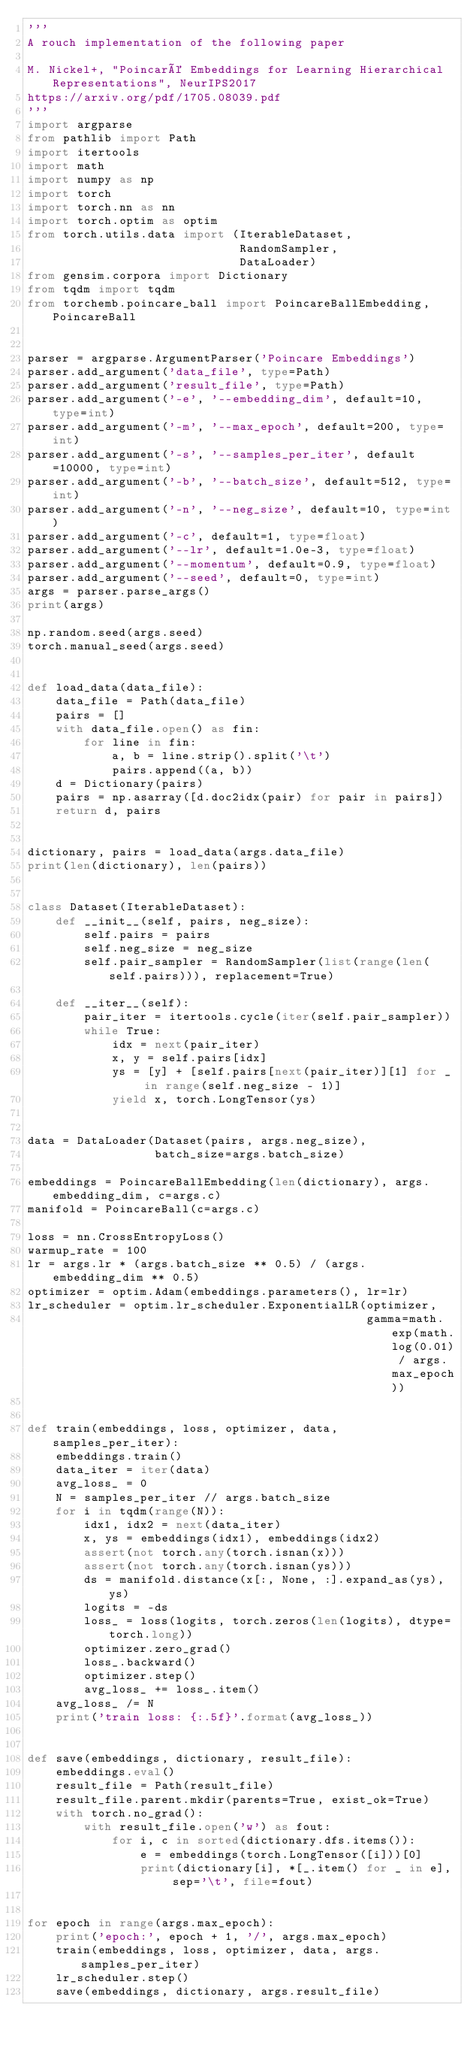<code> <loc_0><loc_0><loc_500><loc_500><_Python_>'''
A rouch implementation of the following paper

M. Nickel+, "Poincaré Embeddings for Learning Hierarchical Representations", NeurIPS2017
https://arxiv.org/pdf/1705.08039.pdf
'''
import argparse
from pathlib import Path
import itertools
import math
import numpy as np
import torch
import torch.nn as nn
import torch.optim as optim
from torch.utils.data import (IterableDataset,
                              RandomSampler,
                              DataLoader)
from gensim.corpora import Dictionary
from tqdm import tqdm
from torchemb.poincare_ball import PoincareBallEmbedding, PoincareBall


parser = argparse.ArgumentParser('Poincare Embeddings')
parser.add_argument('data_file', type=Path)
parser.add_argument('result_file', type=Path)
parser.add_argument('-e', '--embedding_dim', default=10, type=int)
parser.add_argument('-m', '--max_epoch', default=200, type=int)
parser.add_argument('-s', '--samples_per_iter', default=10000, type=int)
parser.add_argument('-b', '--batch_size', default=512, type=int)
parser.add_argument('-n', '--neg_size', default=10, type=int)
parser.add_argument('-c', default=1, type=float)
parser.add_argument('--lr', default=1.0e-3, type=float)
parser.add_argument('--momentum', default=0.9, type=float)
parser.add_argument('--seed', default=0, type=int)
args = parser.parse_args()
print(args)

np.random.seed(args.seed)
torch.manual_seed(args.seed)


def load_data(data_file):
    data_file = Path(data_file)
    pairs = []
    with data_file.open() as fin:
        for line in fin:
            a, b = line.strip().split('\t')
            pairs.append((a, b))
    d = Dictionary(pairs)
    pairs = np.asarray([d.doc2idx(pair) for pair in pairs])
    return d, pairs


dictionary, pairs = load_data(args.data_file)
print(len(dictionary), len(pairs))


class Dataset(IterableDataset):
    def __init__(self, pairs, neg_size):
        self.pairs = pairs
        self.neg_size = neg_size
        self.pair_sampler = RandomSampler(list(range(len(self.pairs))), replacement=True)

    def __iter__(self):
        pair_iter = itertools.cycle(iter(self.pair_sampler))
        while True:
            idx = next(pair_iter)
            x, y = self.pairs[idx]
            ys = [y] + [self.pairs[next(pair_iter)][1] for _ in range(self.neg_size - 1)]
            yield x, torch.LongTensor(ys)


data = DataLoader(Dataset(pairs, args.neg_size),
                  batch_size=args.batch_size)

embeddings = PoincareBallEmbedding(len(dictionary), args.embedding_dim, c=args.c)
manifold = PoincareBall(c=args.c)

loss = nn.CrossEntropyLoss()
warmup_rate = 100
lr = args.lr * (args.batch_size ** 0.5) / (args.embedding_dim ** 0.5)
optimizer = optim.Adam(embeddings.parameters(), lr=lr)
lr_scheduler = optim.lr_scheduler.ExponentialLR(optimizer,
                                                gamma=math.exp(math.log(0.01) / args.max_epoch))


def train(embeddings, loss, optimizer, data, samples_per_iter):
    embeddings.train()
    data_iter = iter(data)
    avg_loss_ = 0
    N = samples_per_iter // args.batch_size
    for i in tqdm(range(N)):
        idx1, idx2 = next(data_iter)
        x, ys = embeddings(idx1), embeddings(idx2)
        assert(not torch.any(torch.isnan(x)))
        assert(not torch.any(torch.isnan(ys)))
        ds = manifold.distance(x[:, None, :].expand_as(ys), ys)
        logits = -ds
        loss_ = loss(logits, torch.zeros(len(logits), dtype=torch.long))
        optimizer.zero_grad()
        loss_.backward()
        optimizer.step()
        avg_loss_ += loss_.item()
    avg_loss_ /= N
    print('train loss: {:.5f}'.format(avg_loss_))


def save(embeddings, dictionary, result_file):
    embeddings.eval()
    result_file = Path(result_file)
    result_file.parent.mkdir(parents=True, exist_ok=True)
    with torch.no_grad():
        with result_file.open('w') as fout:
            for i, c in sorted(dictionary.dfs.items()):
                e = embeddings(torch.LongTensor([i]))[0]
                print(dictionary[i], *[_.item() for _ in e], sep='\t', file=fout)


for epoch in range(args.max_epoch):
    print('epoch:', epoch + 1, '/', args.max_epoch)
    train(embeddings, loss, optimizer, data, args.samples_per_iter)
    lr_scheduler.step()
    save(embeddings, dictionary, args.result_file)
</code> 